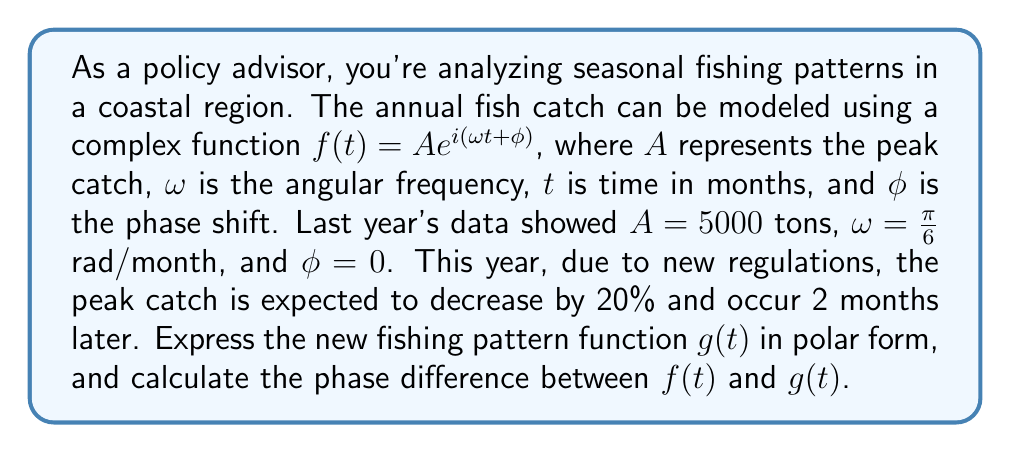Provide a solution to this math problem. Let's approach this step-by-step:

1) The original function is $f(t) = 5000e^{i(\frac{\pi}{6}t)}$

2) For the new function $g(t)$:
   - The peak catch decreases by 20%: $A_{new} = 5000 \cdot 0.8 = 4000$ tons
   - The peak occurs 2 months later, which translates to a phase shift of $\frac{\pi}{3}$ radians:
     $$\phi_{new} = \frac{\pi}{6} \cdot 2 = \frac{\pi}{3}$$

3) Therefore, the new function is:
   $$g(t) = 4000e^{i(\frac{\pi}{6}t + \frac{\pi}{3})}$$

4) To find the phase difference, we compare the arguments of $f(t)$ and $g(t)$:
   $$\text{Phase difference} = \arg(g(t)) - \arg(f(t)) = (\frac{\pi}{6}t + \frac{\pi}{3}) - \frac{\pi}{6}t = \frac{\pi}{3}$$

This phase difference of $\frac{\pi}{3}$ radians corresponds to the 2-month delay in peak catch.
Answer: The new fishing pattern function is $g(t) = 4000e^{i(\frac{\pi}{6}t + \frac{\pi}{3})}$, and the phase difference between $f(t)$ and $g(t)$ is $\frac{\pi}{3}$ radians. 